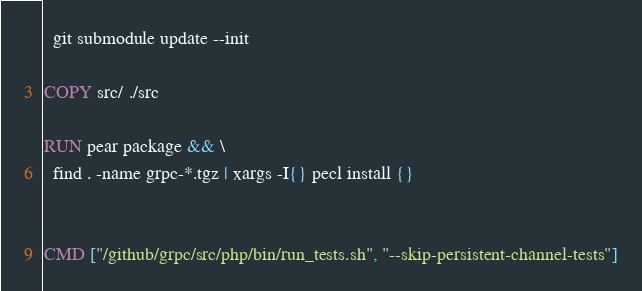<code> <loc_0><loc_0><loc_500><loc_500><_Dockerfile_>  git submodule update --init

COPY src/ ./src

RUN pear package && \
  find . -name grpc-*.tgz | xargs -I{} pecl install {}


CMD ["/github/grpc/src/php/bin/run_tests.sh", "--skip-persistent-channel-tests"]
</code> 